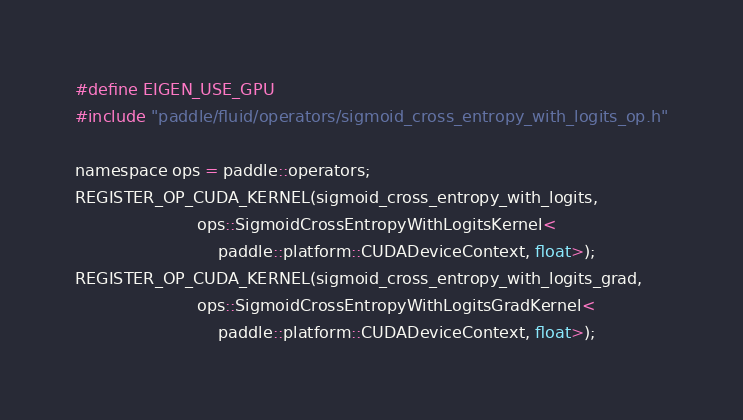<code> <loc_0><loc_0><loc_500><loc_500><_Cuda_>
#define EIGEN_USE_GPU
#include "paddle/fluid/operators/sigmoid_cross_entropy_with_logits_op.h"

namespace ops = paddle::operators;
REGISTER_OP_CUDA_KERNEL(sigmoid_cross_entropy_with_logits,
                        ops::SigmoidCrossEntropyWithLogitsKernel<
                            paddle::platform::CUDADeviceContext, float>);
REGISTER_OP_CUDA_KERNEL(sigmoid_cross_entropy_with_logits_grad,
                        ops::SigmoidCrossEntropyWithLogitsGradKernel<
                            paddle::platform::CUDADeviceContext, float>);
</code> 